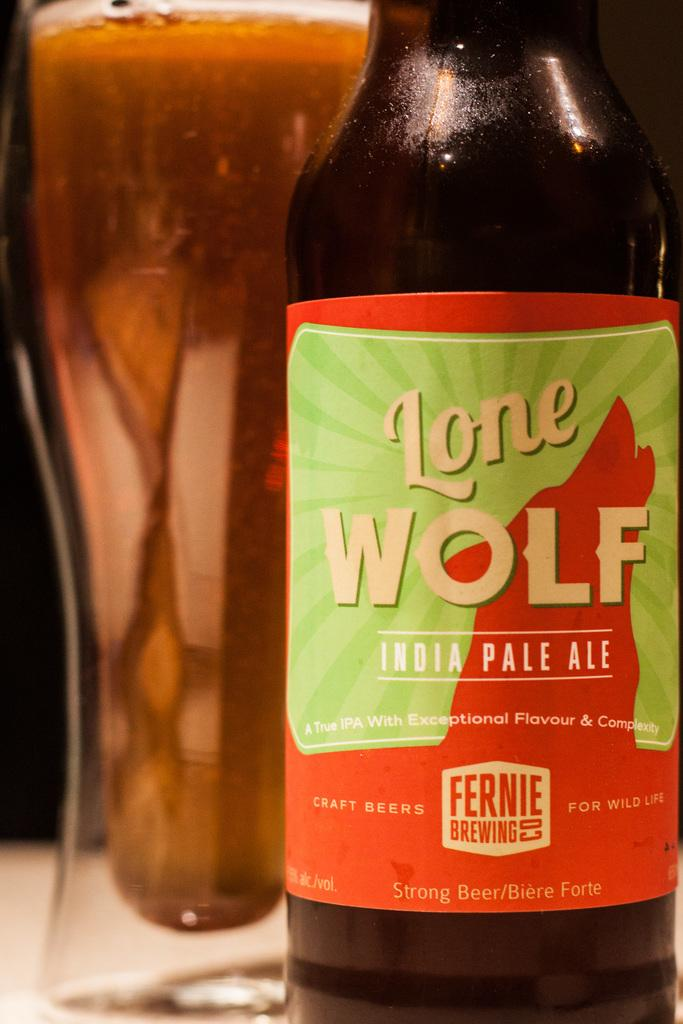<image>
Describe the image concisely. A bottle of Lone Wolf India Pale Ale next to a full glass. 